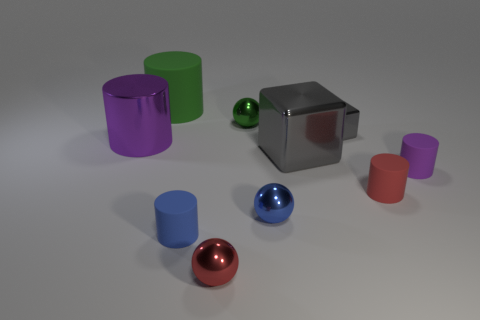Are there any small blue spheres made of the same material as the small red cylinder?
Make the answer very short. No. There is a blue object that is to the left of the green ball; is there a large block in front of it?
Provide a short and direct response. No. What is the ball behind the big cube made of?
Keep it short and to the point. Metal. Does the small purple thing have the same shape as the blue rubber object?
Give a very brief answer. Yes. What is the color of the tiny ball that is behind the gray object that is to the left of the block behind the large gray metal thing?
Give a very brief answer. Green. What number of other gray matte things have the same shape as the big rubber thing?
Your answer should be compact. 0. There is a sphere that is in front of the tiny blue thing on the left side of the green metal thing; what is its size?
Keep it short and to the point. Small. Do the blue cylinder and the green ball have the same size?
Make the answer very short. Yes. There is a red rubber cylinder that is on the right side of the big cylinder in front of the small gray shiny object; is there a tiny ball that is in front of it?
Your answer should be compact. Yes. How big is the purple matte object?
Your answer should be very brief. Small. 